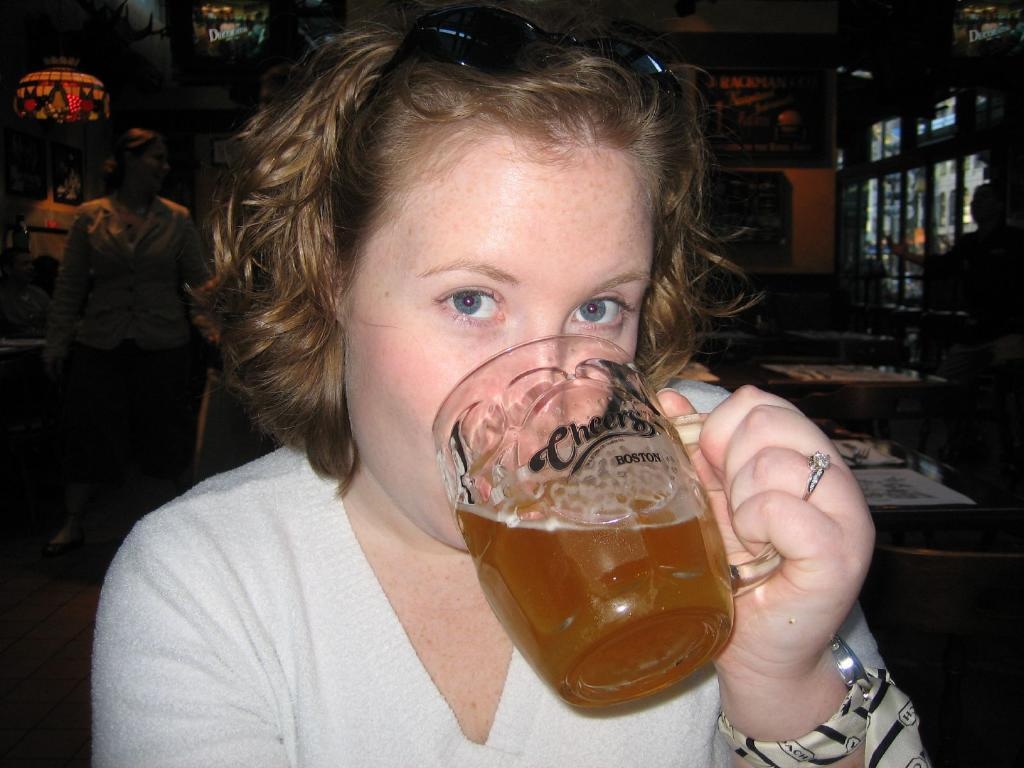Who is the main subject in the picture? There is a woman in the picture. What is the woman wearing? The woman is wearing a white t-shirt. What is the woman holding in the picture? The woman is holding a cup. How far away is the woman from the speaker or camera? The woman is standing far from the speaker or the camera. What type of creature is sitting on the swing in the image? There is no creature or swing present in the image. 